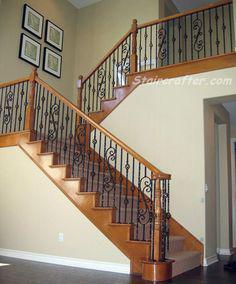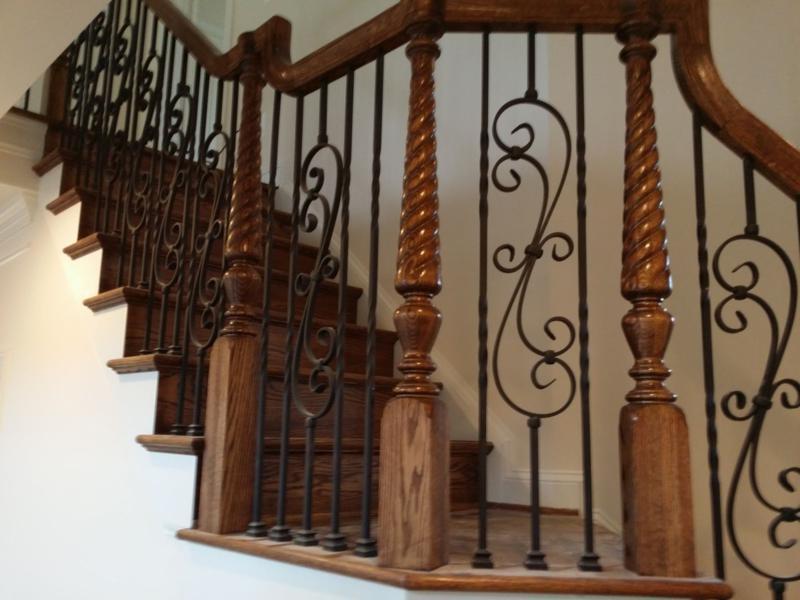The first image is the image on the left, the second image is the image on the right. Given the left and right images, does the statement "The left image shows a leftward ascending staircase with a wooden handrail and black wrought iron bars accented with overlapping scroll shapes." hold true? Answer yes or no. Yes. The first image is the image on the left, the second image is the image on the right. Considering the images on both sides, is "The left and right image contains the same number of staircase with wooden and metal S shaped rails." valid? Answer yes or no. Yes. 